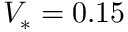<formula> <loc_0><loc_0><loc_500><loc_500>V _ { * } = 0 . 1 5</formula> 